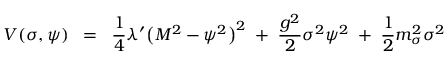<formula> <loc_0><loc_0><loc_500><loc_500>V ( \sigma , \psi ) \, = \, \frac { 1 } { 4 } \lambda ^ { \prime } \left ( M ^ { 2 } - \psi ^ { 2 } \right ) ^ { 2 } \, + \, \frac { g ^ { 2 } } { 2 } \sigma ^ { 2 } \psi ^ { 2 } \, + \, \frac { 1 } { 2 } m _ { \sigma } ^ { 2 } \sigma ^ { 2 }</formula> 